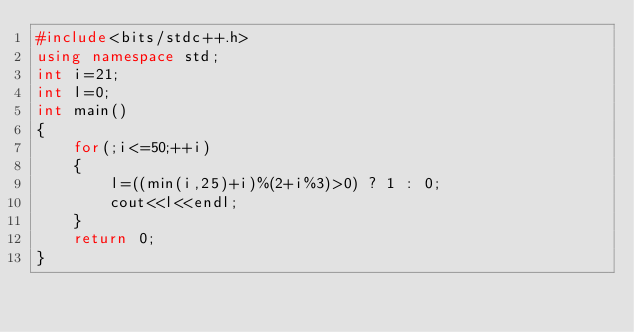<code> <loc_0><loc_0><loc_500><loc_500><_C++_>#include<bits/stdc++.h>
using namespace std;
int i=21;
int l=0;
int main()
{
	for(;i<=50;++i)
	{
		l=((min(i,25)+i)%(2+i%3)>0) ? 1 : 0;
        cout<<l<<endl;
    }
    return 0;
}
</code> 